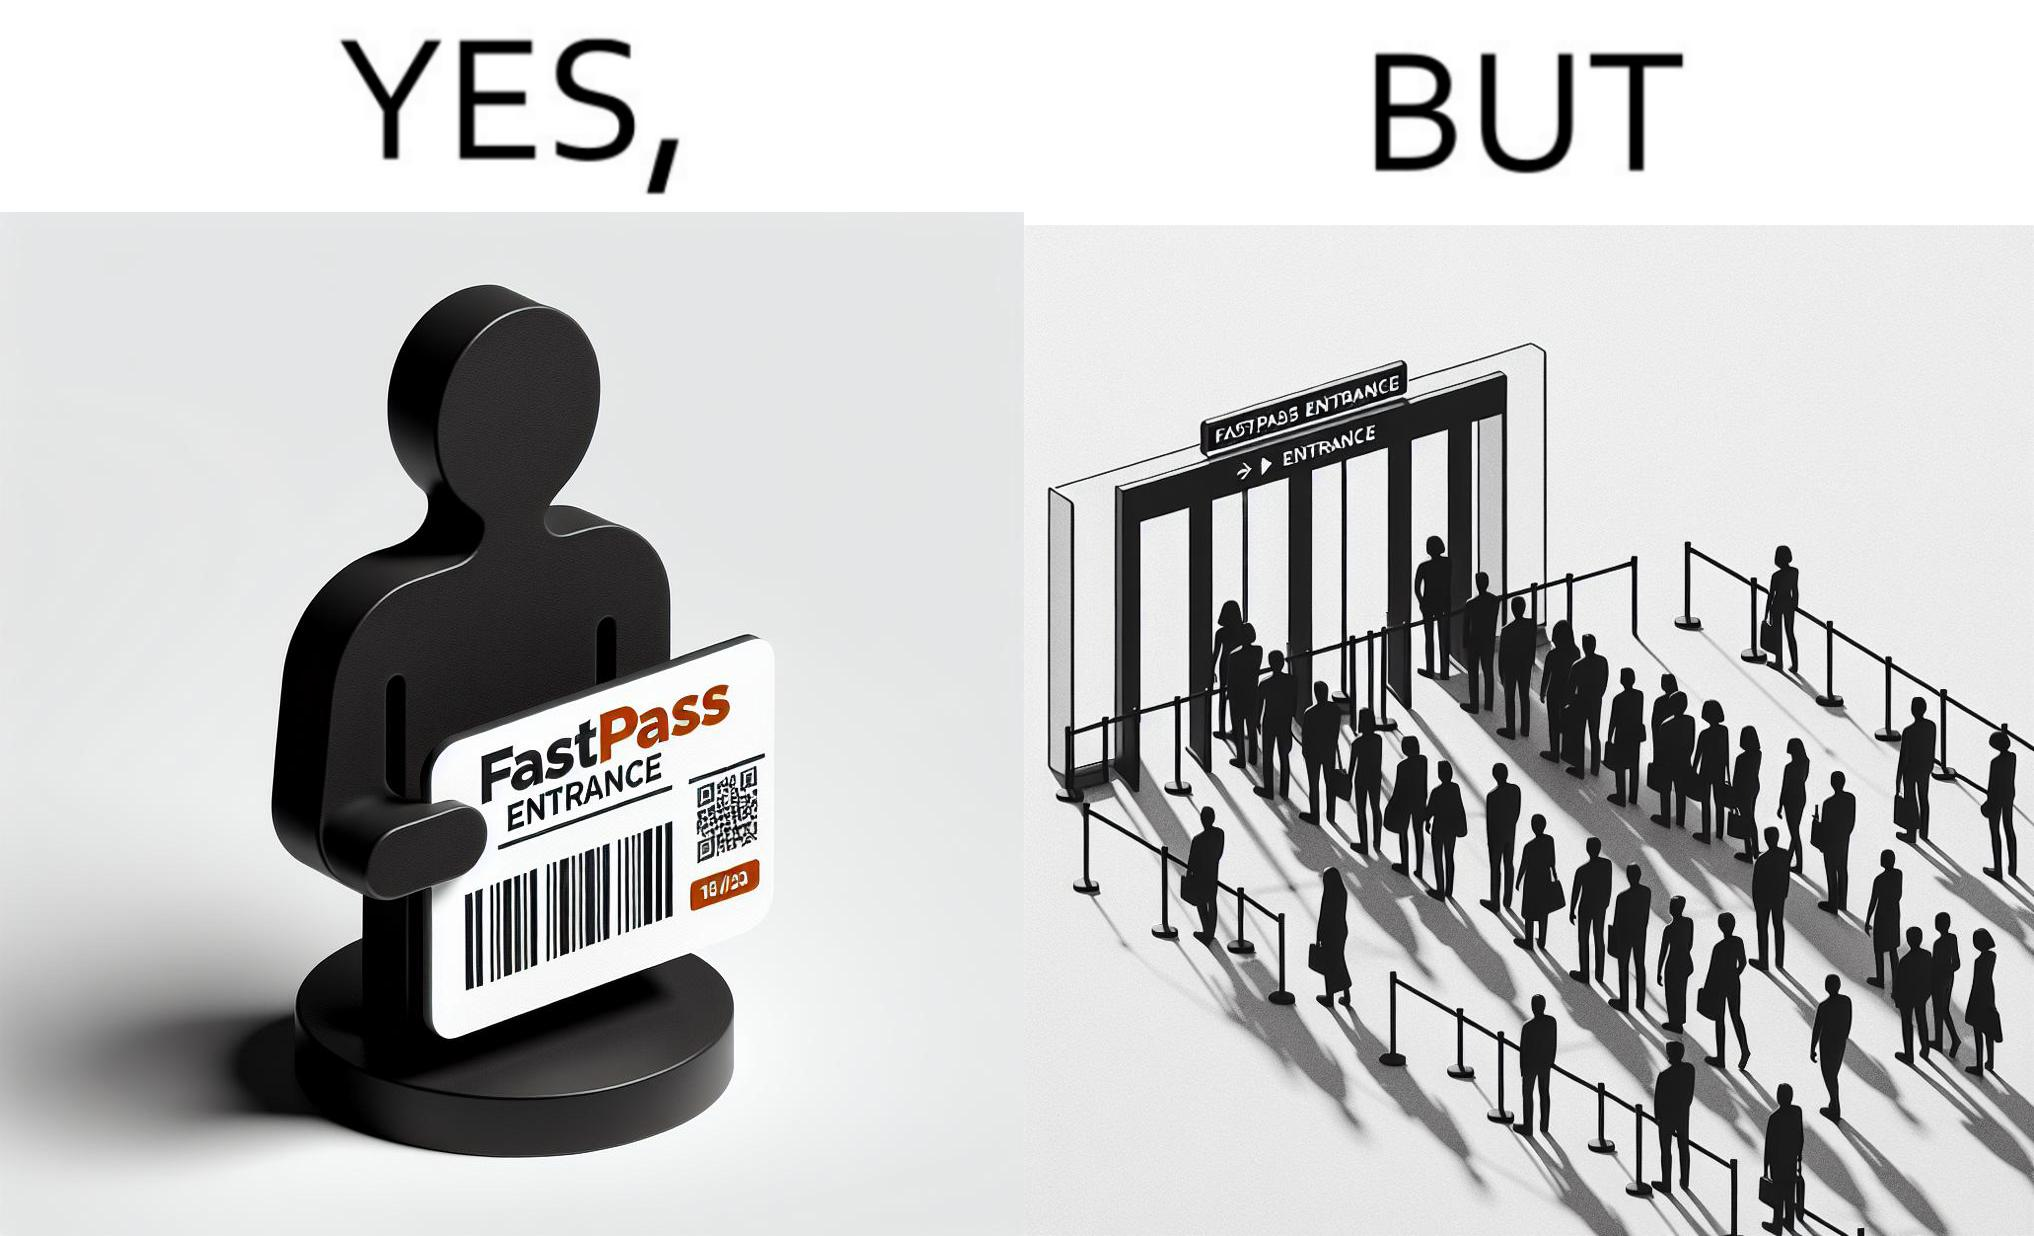Describe what you see in this image. The image is ironic, because fast pass entrance was meant for people to pass the gate fast but as more no. of people bought the pass due to which the queue has become longer and it becomes slow and time consuming 